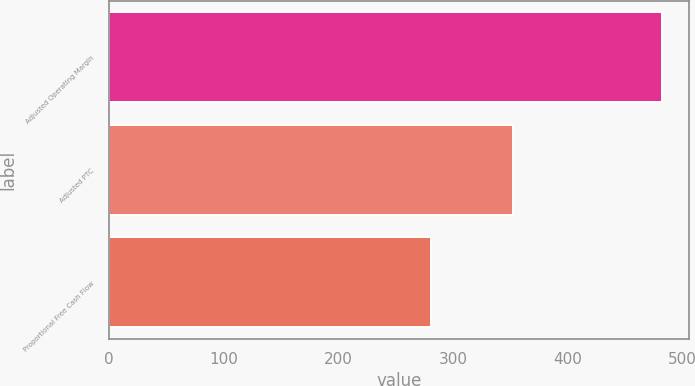Convert chart to OTSL. <chart><loc_0><loc_0><loc_500><loc_500><bar_chart><fcel>Adjusted Operating Margin<fcel>Adjusted PTC<fcel>Proportional Free Cash Flow<nl><fcel>482<fcel>352<fcel>281<nl></chart> 